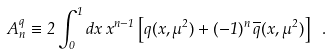<formula> <loc_0><loc_0><loc_500><loc_500>A ^ { q } _ { n } \equiv 2 \int ^ { 1 } _ { 0 } d x \, x ^ { n - 1 } \left [ q ( x , \mu ^ { 2 } ) + ( - 1 ) ^ { n } \, \overline { q } ( x , \mu ^ { 2 } ) \right ] \ .</formula> 